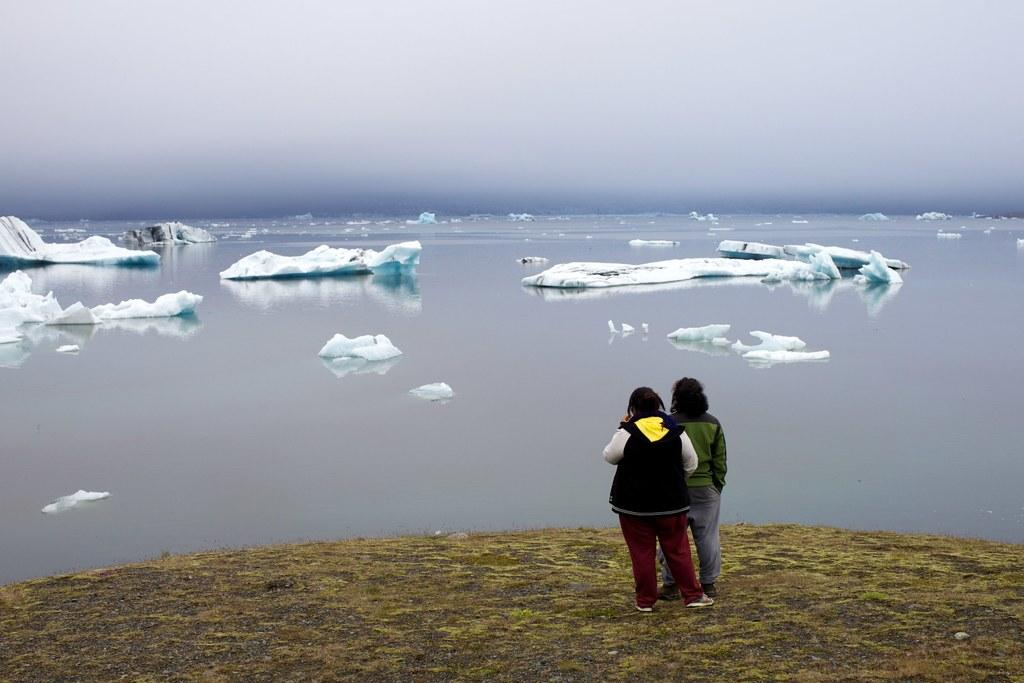How many people are in the image? There are two people in the image. Where are the two people located? The two people are on the floor. What is the most prominent feature in the background of the image? There is an iceberg visible in the image. What is the sister of the person on the left side of the image doing in the image? There is no mention of a sister or any other person besides the two people in the image. 